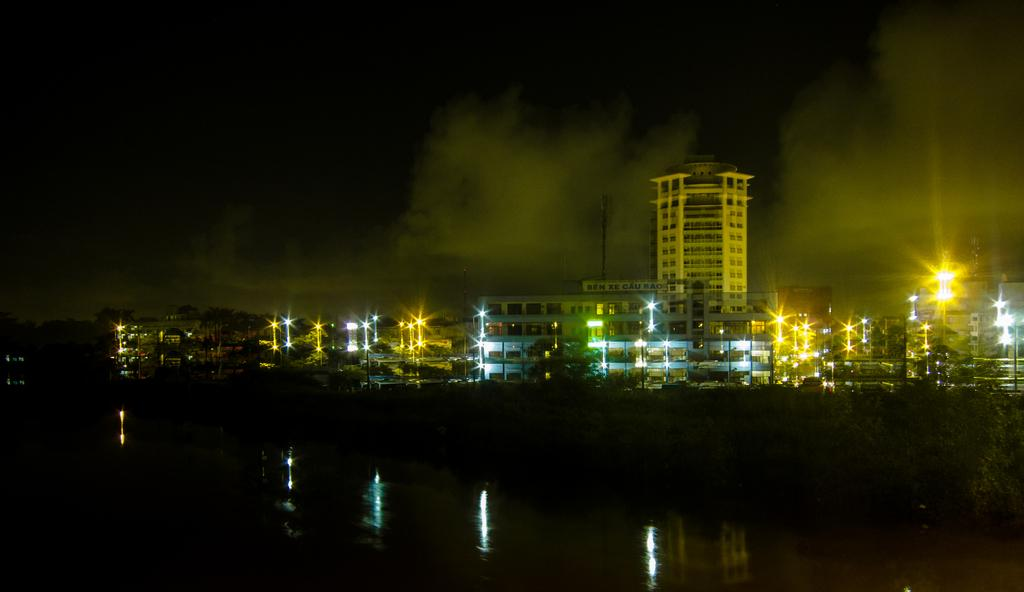What can be seen in the background of the image? In the background of the image, there is water, buildings, and lights. Can you describe the water in the background? The water is visible in the background, but its specific characteristics are not mentioned in the facts. What type of structures can be seen in the background? Buildings are visible in the background of the image. What else is present in the background along with the water and buildings? Lights are present in the background of the image. How many trees are present in the image? There is no mention of trees in the provided facts, so we cannot determine the number of trees in the image. What scientific discoveries are depicted in the image? The image does not depict any scientific discoveries; it features water, buildings, and lights in the background. 